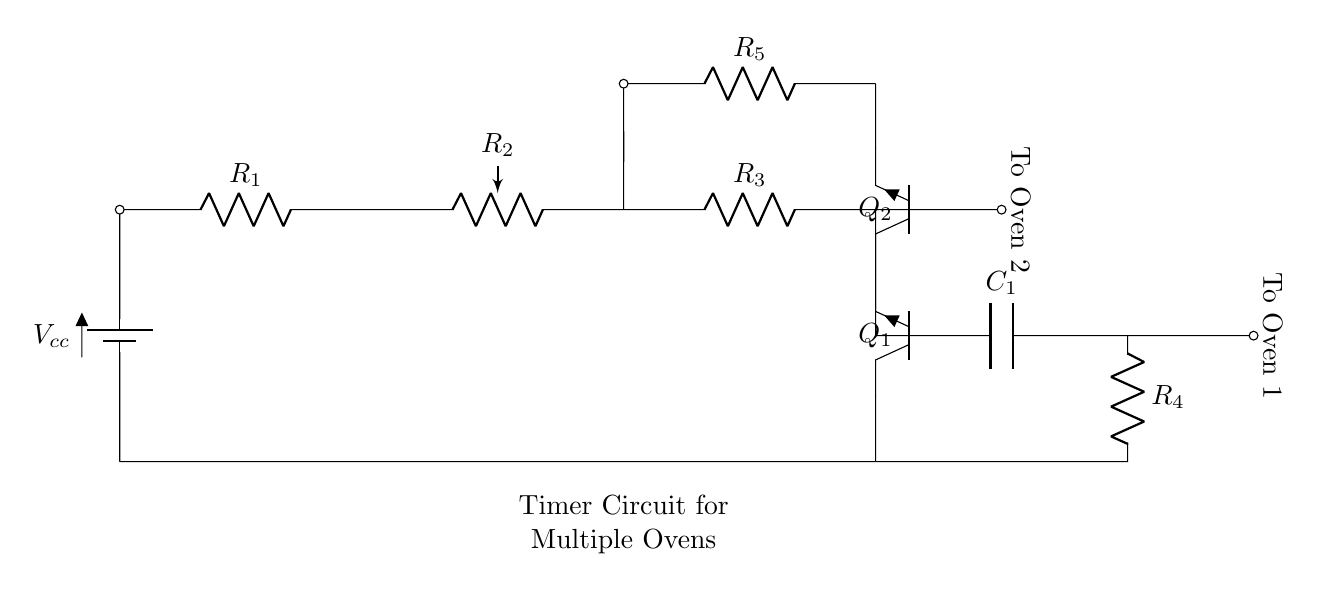What is the total number of resistors in the circuit? There are four resistors labeled as R1, R3, R4, and R5 in the circuit diagram. Counting them gives a total of four resistors.
Answer: four What is the function of capacitor C1 in this circuit? Capacitor C1 likely acts as a timing element in this timer circuit, storing and releasing charge to influence the timing intervals for controlling the ovens.
Answer: timing element How many transistors are used in the circuit? The circuit includes two transistors, identified as Q1 and Q2. The count of these devices based on the diagram shows there are two transistors.
Answer: two What is the configuration of R2 in the circuit? R2 is a potentiometer, which means it can vary its resistance over a range, allowing for adjustable settings in the circuit.
Answer: potentiometer What is the direction of current flow towards Oven 1? The current flows from the battery through R1, R2, and R3, then to Q1 and finally directed towards Oven 1, following a specific path defined by the circuit connections.
Answer: from battery to Oven 1 Why are there two outputs for ovens in this timer circuit? The timer circuit is designed for multiple ovens; having two outputs allows for independent control of each oven, facilitating efficient baking management for the bakery.
Answer: independent control of each oven What component connects to Oven 2? The connection to Oven 2 is made at the end of R3, which is directly linked to Q2, allowing both control and powering of the second oven.
Answer: R3 to Q2 